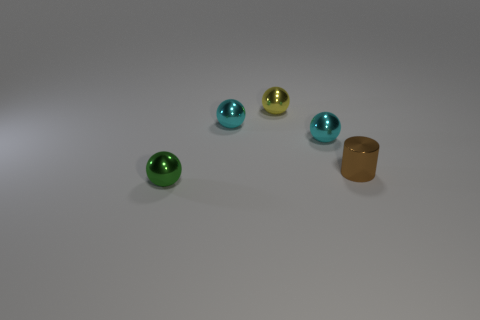Is the number of small brown objects in front of the tiny green thing greater than the number of tiny cyan metal balls?
Your response must be concise. No. The small brown metallic object that is right of the small yellow sphere has what shape?
Offer a terse response. Cylinder. What number of other things are the same shape as the tiny yellow thing?
Offer a terse response. 3. Is the yellow object that is left of the brown object made of the same material as the brown object?
Ensure brevity in your answer.  Yes. Is the number of tiny brown objects that are in front of the brown thing the same as the number of yellow metallic things that are right of the yellow object?
Provide a short and direct response. Yes. What size is the green metallic ball that is in front of the small brown thing?
Keep it short and to the point. Small. Is there a big gray sphere made of the same material as the cylinder?
Provide a short and direct response. No. There is a tiny sphere to the right of the yellow object; is it the same color as the cylinder?
Ensure brevity in your answer.  No. Are there an equal number of small cylinders on the left side of the small green metallic ball and green metal balls?
Offer a terse response. No. Is the yellow metal sphere the same size as the green thing?
Provide a succinct answer. Yes. 